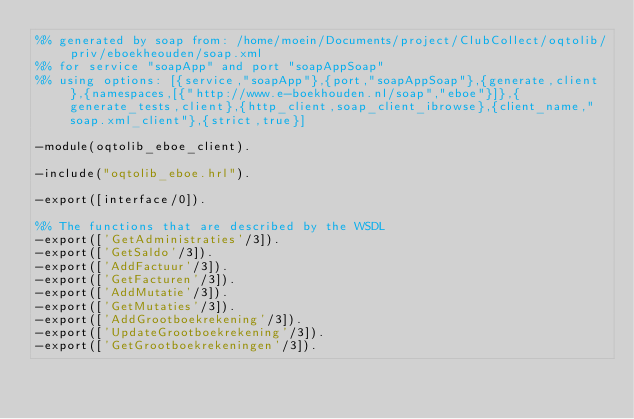Convert code to text. <code><loc_0><loc_0><loc_500><loc_500><_Erlang_>%% generated by soap from: /home/moein/Documents/project/ClubCollect/oqtolib/priv/eboekheouden/soap.xml
%% for service "soapApp" and port "soapAppSoap"
%% using options: [{service,"soapApp"},{port,"soapAppSoap"},{generate,client},{namespaces,[{"http://www.e-boekhouden.nl/soap","eboe"}]},{generate_tests,client},{http_client,soap_client_ibrowse},{client_name,"soap.xml_client"},{strict,true}]

-module(oqtolib_eboe_client).

-include("oqtolib_eboe.hrl").

-export([interface/0]).

%% The functions that are described by the WSDL
-export(['GetAdministraties'/3]).
-export(['GetSaldo'/3]).
-export(['AddFactuur'/3]).
-export(['GetFacturen'/3]).
-export(['AddMutatie'/3]).
-export(['GetMutaties'/3]).
-export(['AddGrootboekrekening'/3]).
-export(['UpdateGrootboekrekening'/3]).
-export(['GetGrootboekrekeningen'/3]).</code> 